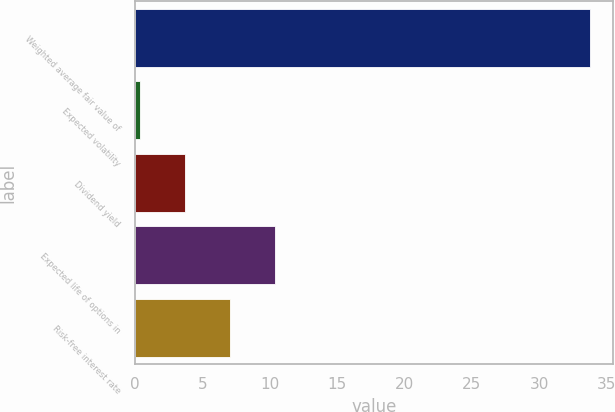Convert chart to OTSL. <chart><loc_0><loc_0><loc_500><loc_500><bar_chart><fcel>Weighted average fair value of<fcel>Expected volatility<fcel>Dividend yield<fcel>Expected life of options in<fcel>Risk-free interest rate<nl><fcel>33.81<fcel>0.37<fcel>3.71<fcel>10.39<fcel>7.05<nl></chart> 